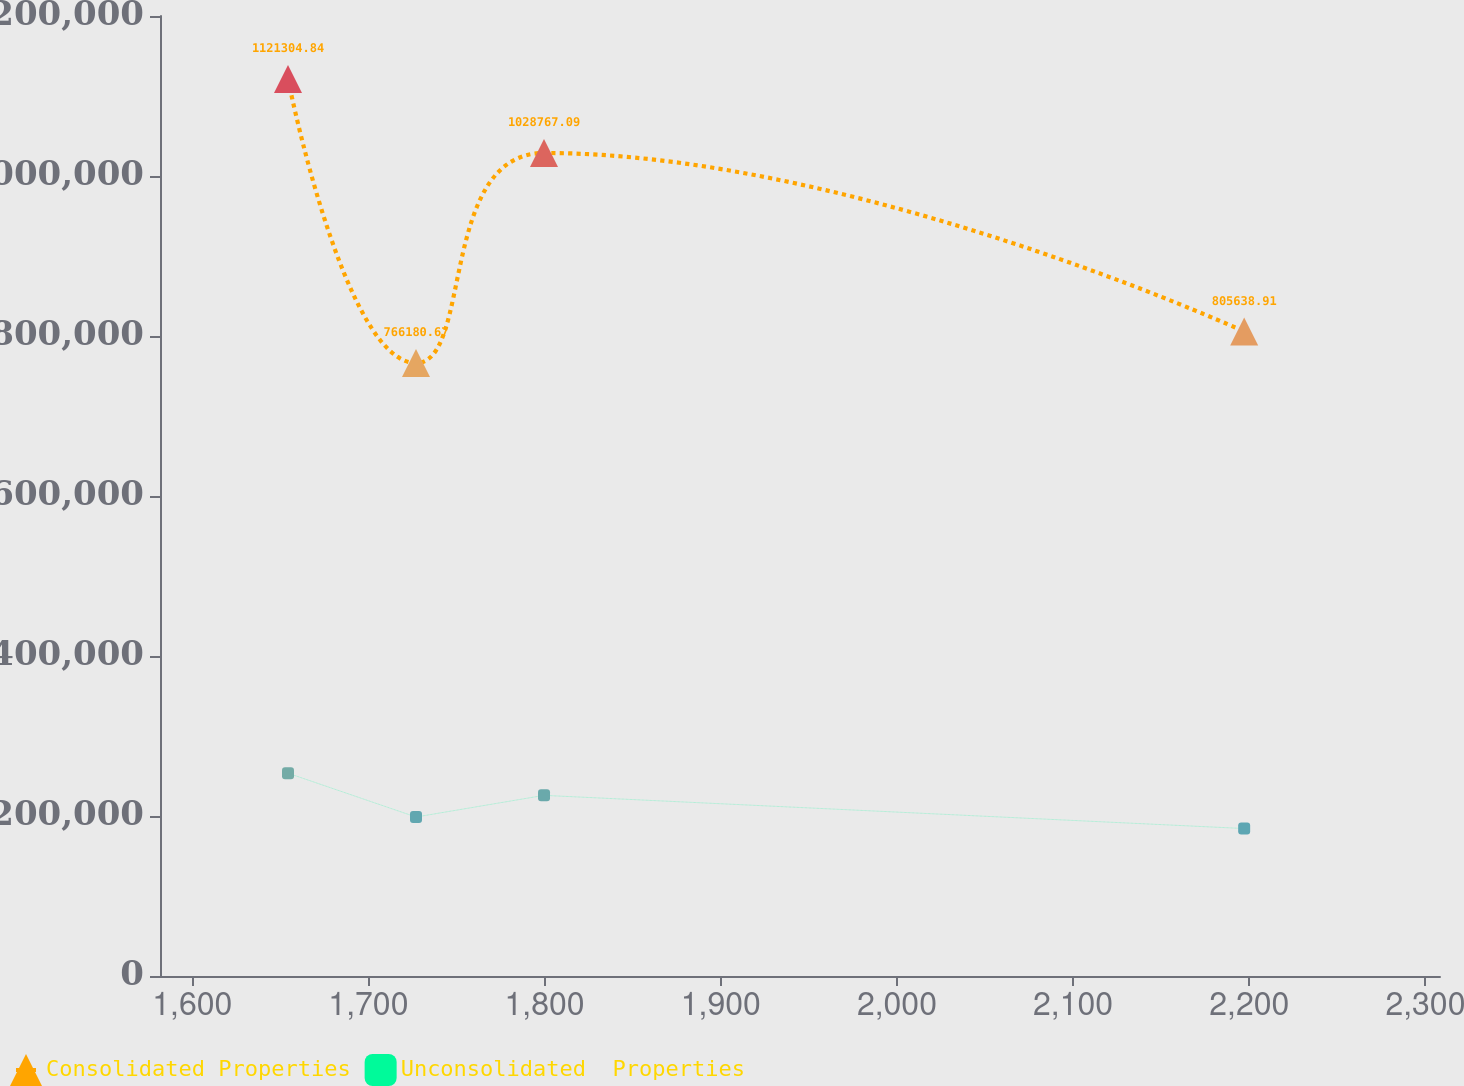Convert chart. <chart><loc_0><loc_0><loc_500><loc_500><line_chart><ecel><fcel>Consolidated Properties<fcel>Unconsolidated  Properties<nl><fcel>1654.36<fcel>1.1213e+06<fcel>253520<nl><fcel>1727.02<fcel>766181<fcel>198730<nl><fcel>1799.68<fcel>1.02877e+06<fcel>225798<nl><fcel>2197.11<fcel>805639<fcel>184318<nl><fcel>2380.93<fcel>726722<fcel>143501<nl></chart> 